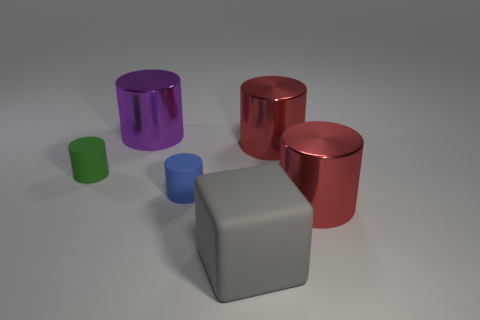Subtract all gray balls. How many red cylinders are left? 2 Subtract all red cylinders. How many cylinders are left? 3 Subtract all blue matte cylinders. How many cylinders are left? 4 Add 3 big cubes. How many objects exist? 9 Subtract all cylinders. How many objects are left? 1 Subtract all yellow cylinders. Subtract all purple blocks. How many cylinders are left? 5 Add 2 blue objects. How many blue objects exist? 3 Subtract 1 blue cylinders. How many objects are left? 5 Subtract all yellow blocks. Subtract all tiny blue cylinders. How many objects are left? 5 Add 5 tiny matte things. How many tiny matte things are left? 7 